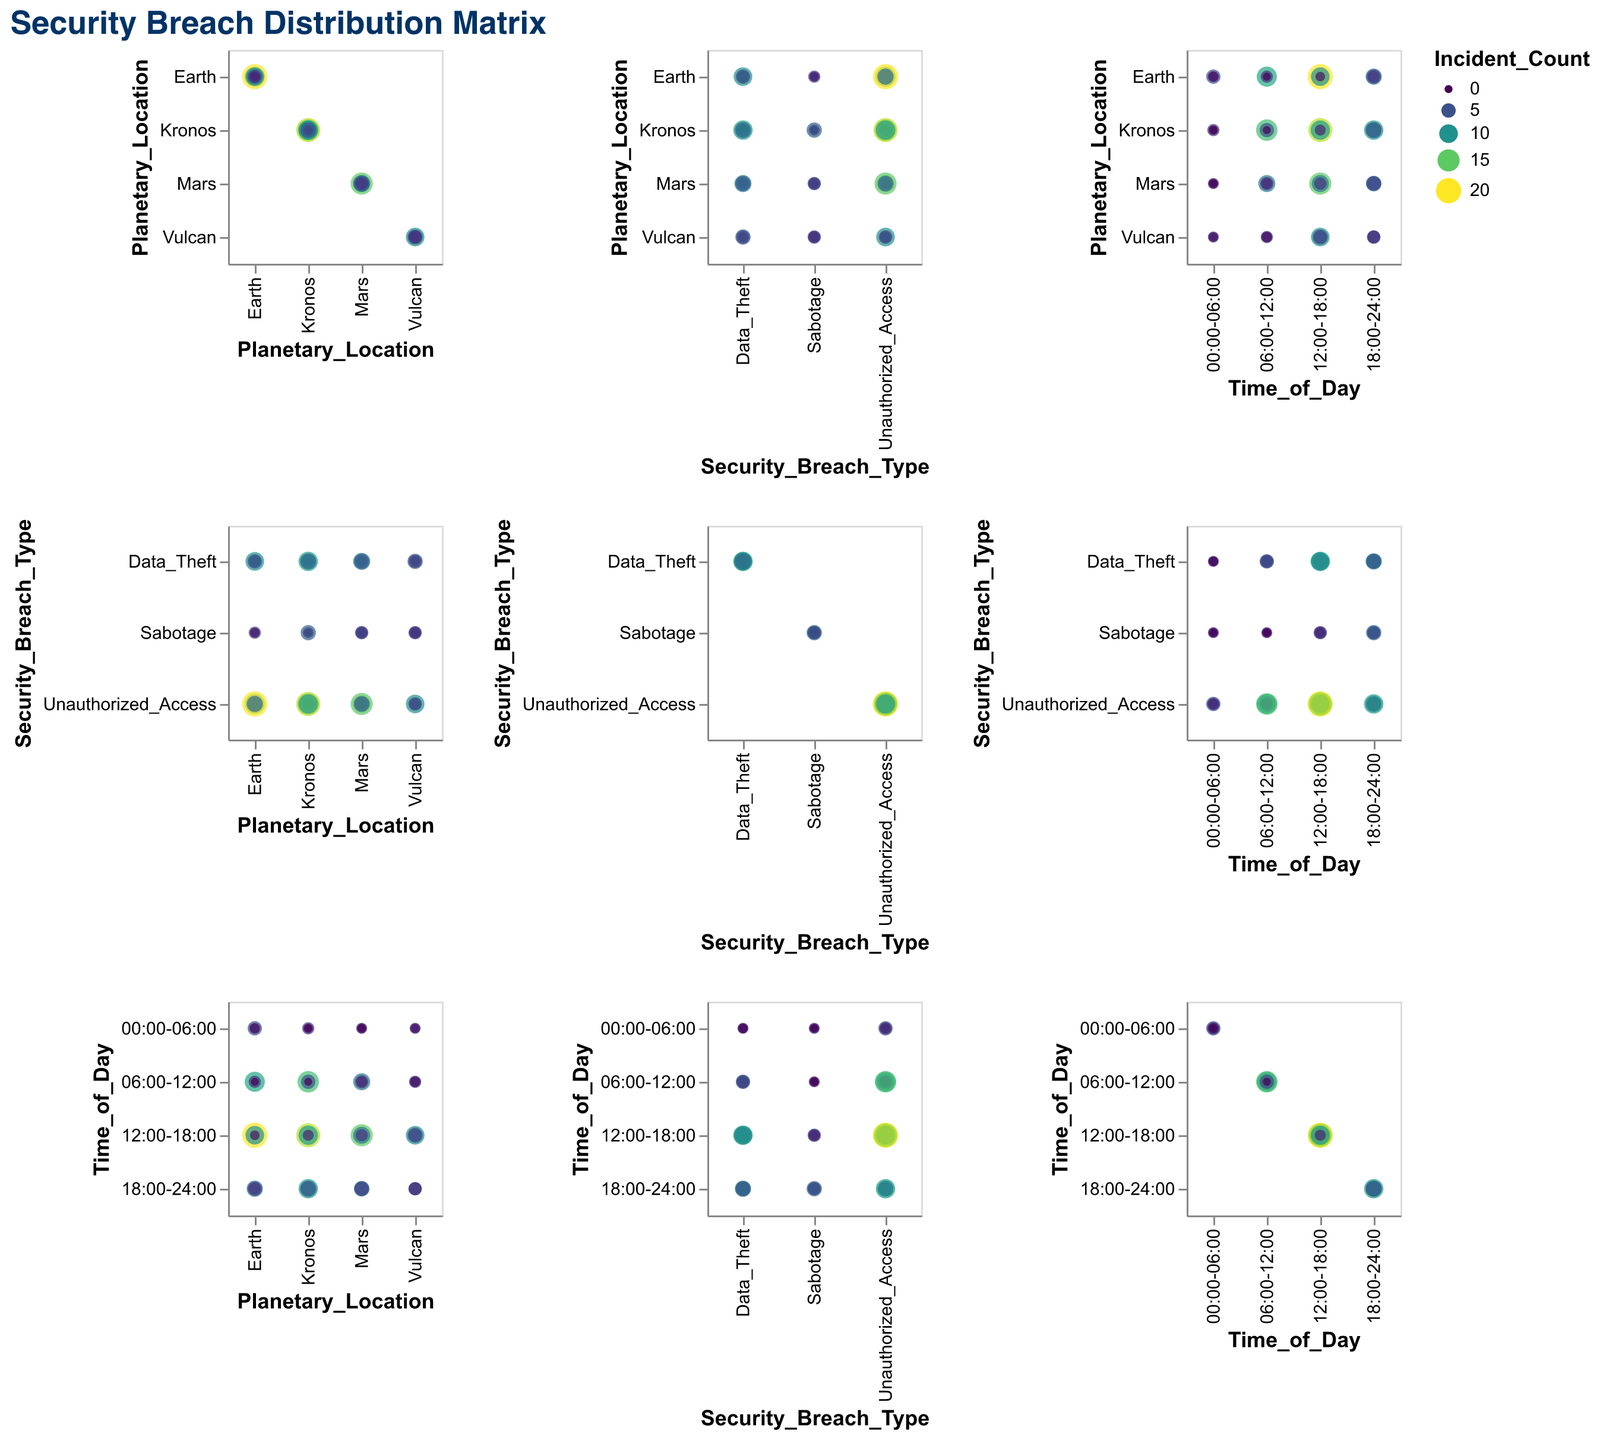What's the title of the figure? The title of the figure is written at the top. It is "Security Breach Distribution Matrix".
Answer: Security Breach Distribution Matrix Which time of day has the highest incident count for Unauthorized Access on Earth? In the figure, look at the row for "Unauthorized_Access" and the column for "Earth". Check the color and size of points representing different times of day. The largest point with the darkest color is between 12:00-18:00.
Answer: 12:00-18:00 Between Earth and Mars, which planetary location has more Sabotage incidents during 12:00-18:00? Check the row for "Sabotage" and the 12:00-18:00 column for both Earth and Mars. The size and color of the points indicate that Mars has a larger and darker point compared to Earth.
Answer: Mars What is the total number of Data Theft incidents on Kronos throughout the day? Sum the Incident_Count for Data Theft on Kronos by looking at all time segments on Kronos row for Data Theft. The values are 1 (00:00-06:00) + 5 (06:00-12:00) + 11 (12:00-18:00) + 7 (18:00-24:00).
Answer: 24 Compare Data Theft incidents on Vulcan during 00:00-06:00 and 18:00-24:00. Which time has more incidents? Look at the row for 'Data_Theft' and the column for 'Vulcan'. Find the columns for 00:00-06:00 and 18:00-24:00 and compare the incident counts. 00:00-06:00 has 0, while 18:00-24:00 has 4.
Answer: 18:00-24:00 Is there any time segment where Sabotage incidents are zero for any planetary location? Check all rows labeled 'Sabotage' across different columns (planetary locations) and identify any zero values in incident counts. Earth at 06:00-12:00 and Kronos at 00:00-06:00 & 06:00-12:00 have zero incidents.
Answer: Yes What is the average number of Unauthorized Access incidents on Mars for the entire day? Sum the Incident_Count for Unauthorized Access on Mars across all time segments and divide by the number of segments. The values are 2 + 8 + 15 + 6; Total = 31, and there are 4 segments.
Answer: 7.75 Which planetary location has more overall security breaches for sabotages, Earth or Vulcan? Sum the Incident_Count for all Sabotage incidents on Earth and Vulcan. Earth values: 1 (00:00-06:00) + 0 (06:00-12:00) + 1 (12:00-18:00) + 3 (18:00-24:00); Total = 5. Vulcan values: 2 (00:00-06:00) + 1 (06:00-12:00) + 4 (12:00-18:00) + 3 (18:00-24:00); Total = 10.
Answer: Vulcan 